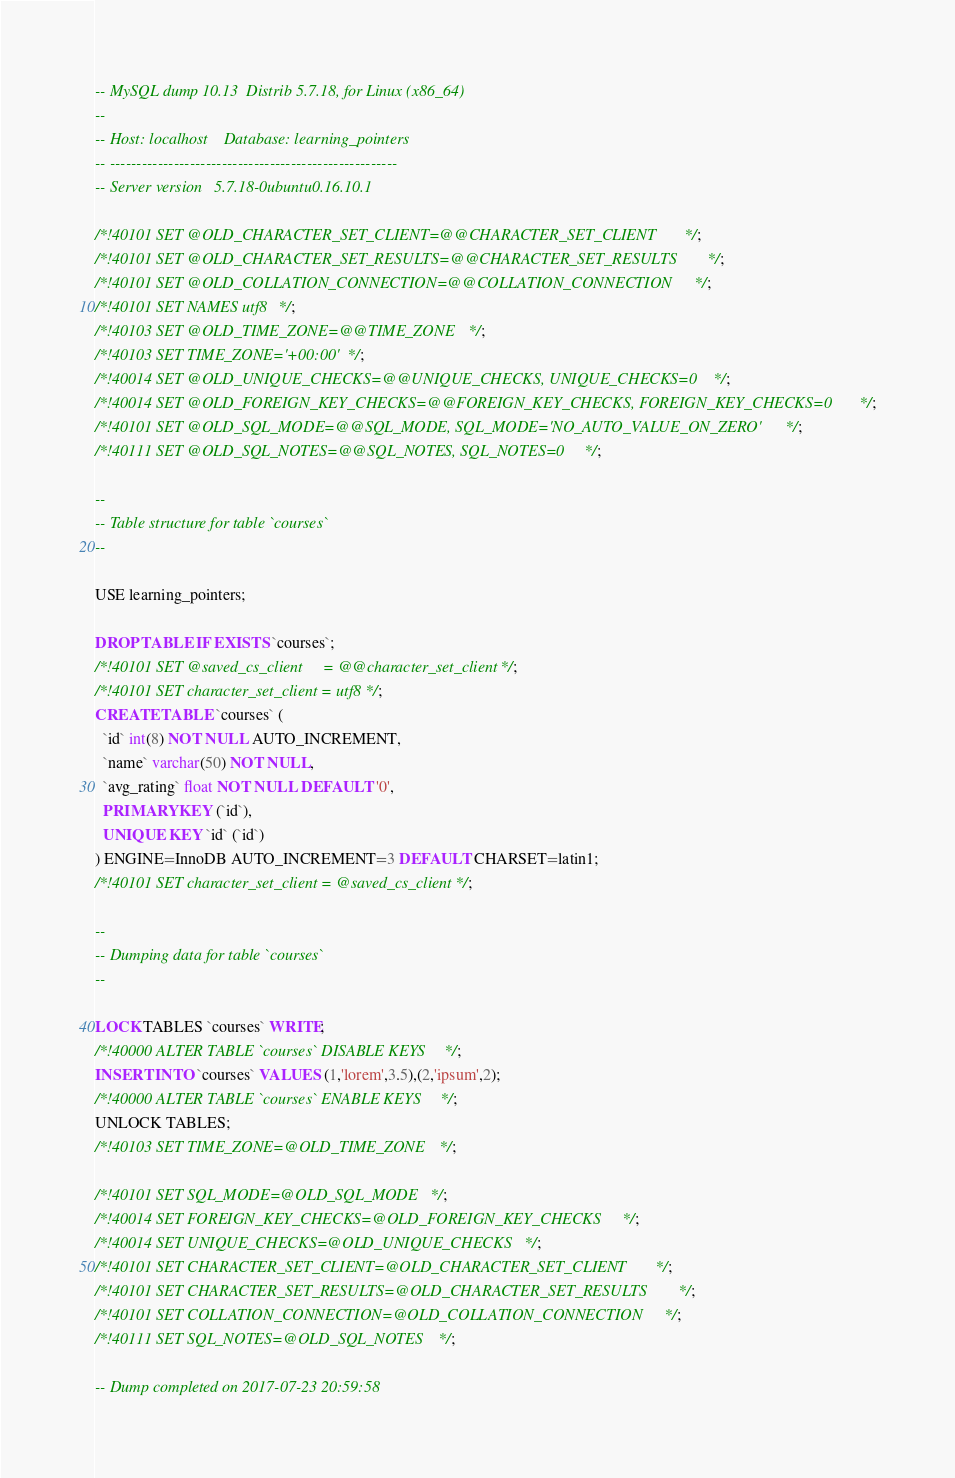<code> <loc_0><loc_0><loc_500><loc_500><_SQL_>-- MySQL dump 10.13  Distrib 5.7.18, for Linux (x86_64)
--
-- Host: localhost    Database: learning_pointers
-- ------------------------------------------------------
-- Server version	5.7.18-0ubuntu0.16.10.1

/*!40101 SET @OLD_CHARACTER_SET_CLIENT=@@CHARACTER_SET_CLIENT */;
/*!40101 SET @OLD_CHARACTER_SET_RESULTS=@@CHARACTER_SET_RESULTS */;
/*!40101 SET @OLD_COLLATION_CONNECTION=@@COLLATION_CONNECTION */;
/*!40101 SET NAMES utf8 */;
/*!40103 SET @OLD_TIME_ZONE=@@TIME_ZONE */;
/*!40103 SET TIME_ZONE='+00:00' */;
/*!40014 SET @OLD_UNIQUE_CHECKS=@@UNIQUE_CHECKS, UNIQUE_CHECKS=0 */;
/*!40014 SET @OLD_FOREIGN_KEY_CHECKS=@@FOREIGN_KEY_CHECKS, FOREIGN_KEY_CHECKS=0 */;
/*!40101 SET @OLD_SQL_MODE=@@SQL_MODE, SQL_MODE='NO_AUTO_VALUE_ON_ZERO' */;
/*!40111 SET @OLD_SQL_NOTES=@@SQL_NOTES, SQL_NOTES=0 */;

--
-- Table structure for table `courses`
--

USE learning_pointers;

DROP TABLE IF EXISTS `courses`;
/*!40101 SET @saved_cs_client     = @@character_set_client */;
/*!40101 SET character_set_client = utf8 */;
CREATE TABLE `courses` (
  `id` int(8) NOT NULL AUTO_INCREMENT,
  `name` varchar(50) NOT NULL,
  `avg_rating` float NOT NULL DEFAULT '0',
  PRIMARY KEY (`id`),
  UNIQUE KEY `id` (`id`)
) ENGINE=InnoDB AUTO_INCREMENT=3 DEFAULT CHARSET=latin1;
/*!40101 SET character_set_client = @saved_cs_client */;

--
-- Dumping data for table `courses`
--

LOCK TABLES `courses` WRITE;
/*!40000 ALTER TABLE `courses` DISABLE KEYS */;
INSERT INTO `courses` VALUES (1,'lorem',3.5),(2,'ipsum',2);
/*!40000 ALTER TABLE `courses` ENABLE KEYS */;
UNLOCK TABLES;
/*!40103 SET TIME_ZONE=@OLD_TIME_ZONE */;

/*!40101 SET SQL_MODE=@OLD_SQL_MODE */;
/*!40014 SET FOREIGN_KEY_CHECKS=@OLD_FOREIGN_KEY_CHECKS */;
/*!40014 SET UNIQUE_CHECKS=@OLD_UNIQUE_CHECKS */;
/*!40101 SET CHARACTER_SET_CLIENT=@OLD_CHARACTER_SET_CLIENT */;
/*!40101 SET CHARACTER_SET_RESULTS=@OLD_CHARACTER_SET_RESULTS */;
/*!40101 SET COLLATION_CONNECTION=@OLD_COLLATION_CONNECTION */;
/*!40111 SET SQL_NOTES=@OLD_SQL_NOTES */;

-- Dump completed on 2017-07-23 20:59:58
</code> 